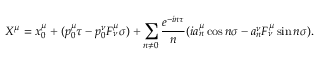<formula> <loc_0><loc_0><loc_500><loc_500>X ^ { \mu } = x _ { 0 } ^ { \mu } + ( p _ { 0 } ^ { \mu } \tau - p _ { 0 } ^ { \nu } F _ { \nu } ^ { \mu } \sigma ) + \sum _ { n \neq 0 } { \frac { e ^ { - i n \tau } } { n } } ( i a _ { n } ^ { \mu } \cos n \sigma - a _ { n } ^ { \nu } F _ { \nu } ^ { \mu } \sin n \sigma ) .</formula> 